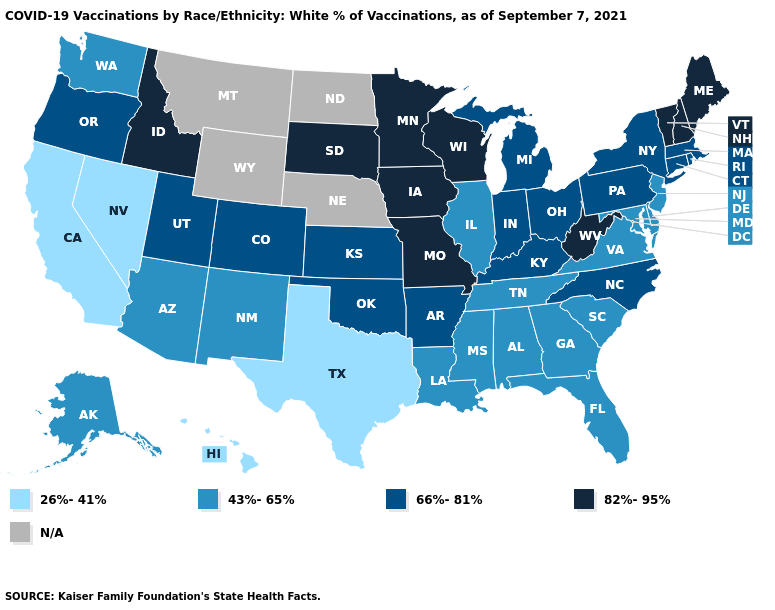Which states have the lowest value in the USA?
Quick response, please. California, Hawaii, Nevada, Texas. What is the value of Illinois?
Give a very brief answer. 43%-65%. Name the states that have a value in the range 82%-95%?
Quick response, please. Idaho, Iowa, Maine, Minnesota, Missouri, New Hampshire, South Dakota, Vermont, West Virginia, Wisconsin. Does Missouri have the highest value in the MidWest?
Answer briefly. Yes. Does New York have the lowest value in the USA?
Answer briefly. No. What is the value of Indiana?
Quick response, please. 66%-81%. What is the highest value in states that border Rhode Island?
Keep it brief. 66%-81%. Does Iowa have the lowest value in the USA?
Quick response, please. No. What is the value of Kentucky?
Write a very short answer. 66%-81%. Is the legend a continuous bar?
Keep it brief. No. What is the highest value in states that border Ohio?
Keep it brief. 82%-95%. Name the states that have a value in the range 66%-81%?
Short answer required. Arkansas, Colorado, Connecticut, Indiana, Kansas, Kentucky, Massachusetts, Michigan, New York, North Carolina, Ohio, Oklahoma, Oregon, Pennsylvania, Rhode Island, Utah. 